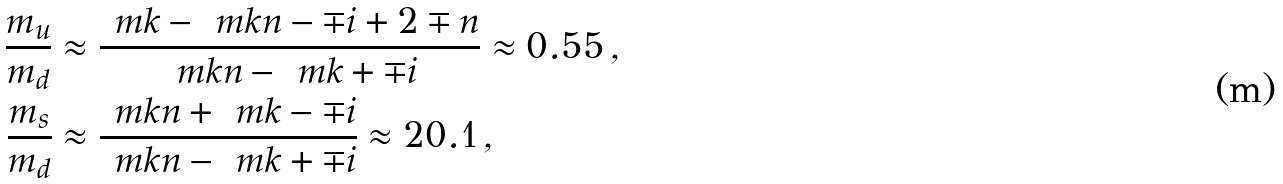<formula> <loc_0><loc_0><loc_500><loc_500>\frac { m _ { u } } { m _ { d } } & \approx \frac { \ m k - \ m k n - \mp i + 2 \mp n } { \ m k n - \ m k + \mp i } \approx 0 . 5 5 \, , \\ \frac { m _ { s } } { m _ { d } } & \approx \frac { \ m k n + \ m k - \mp i } { \ m k n - \ m k + \mp i } \approx 2 0 . 1 \, ,</formula> 